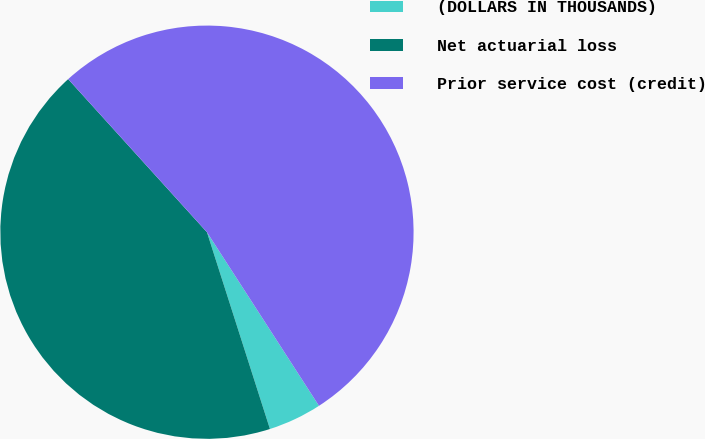<chart> <loc_0><loc_0><loc_500><loc_500><pie_chart><fcel>(DOLLARS IN THOUSANDS)<fcel>Net actuarial loss<fcel>Prior service cost (credit)<nl><fcel>4.19%<fcel>43.21%<fcel>52.6%<nl></chart> 